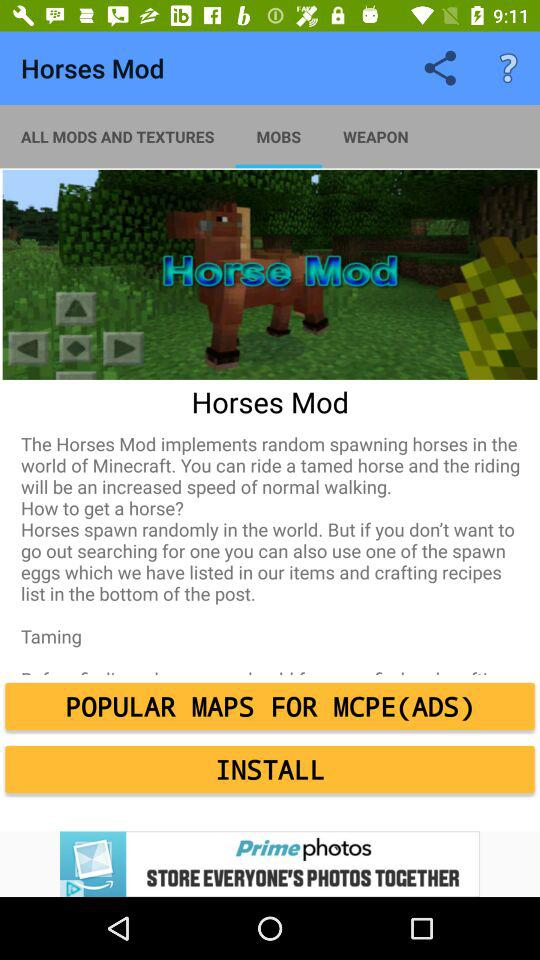Through which applications can this be shared?
When the provided information is insufficient, respond with <no answer>. <no answer> 